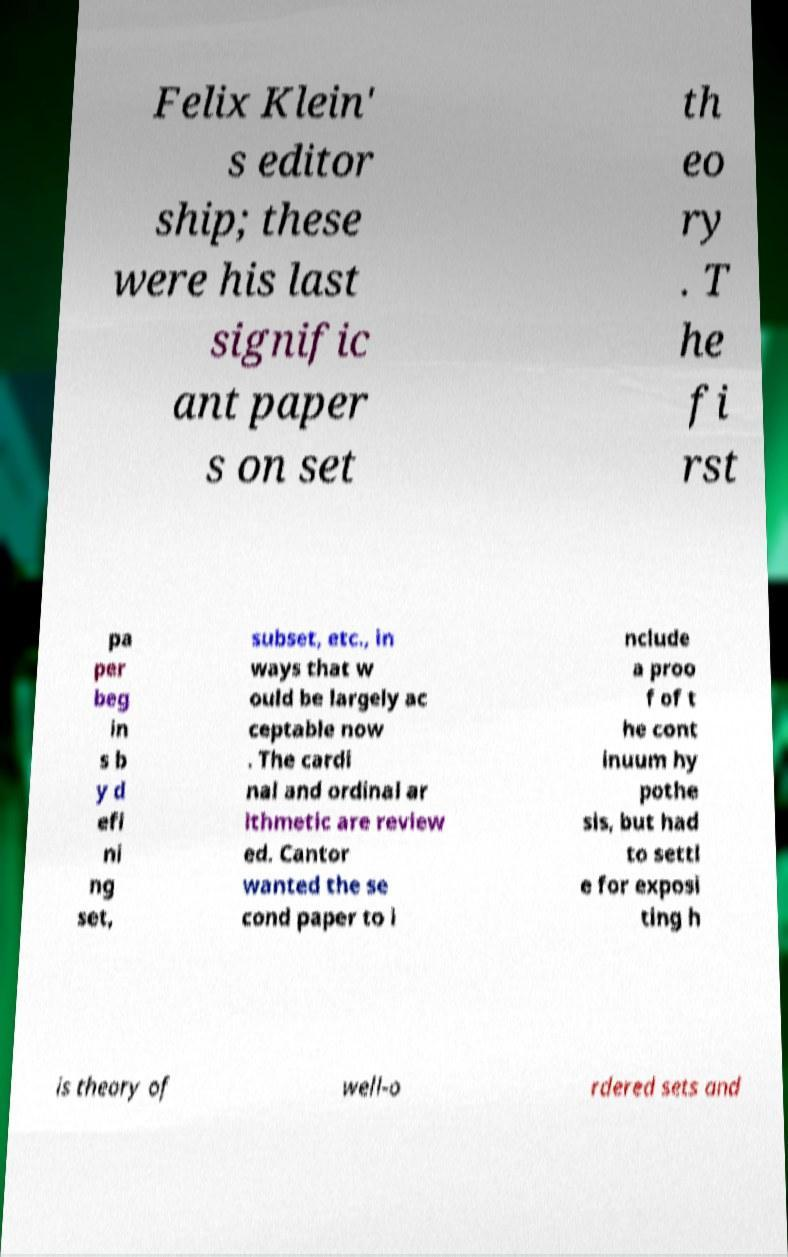There's text embedded in this image that I need extracted. Can you transcribe it verbatim? Felix Klein' s editor ship; these were his last signific ant paper s on set th eo ry . T he fi rst pa per beg in s b y d efi ni ng set, subset, etc., in ways that w ould be largely ac ceptable now . The cardi nal and ordinal ar ithmetic are review ed. Cantor wanted the se cond paper to i nclude a proo f of t he cont inuum hy pothe sis, but had to settl e for exposi ting h is theory of well-o rdered sets and 